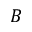Convert formula to latex. <formula><loc_0><loc_0><loc_500><loc_500>B</formula> 